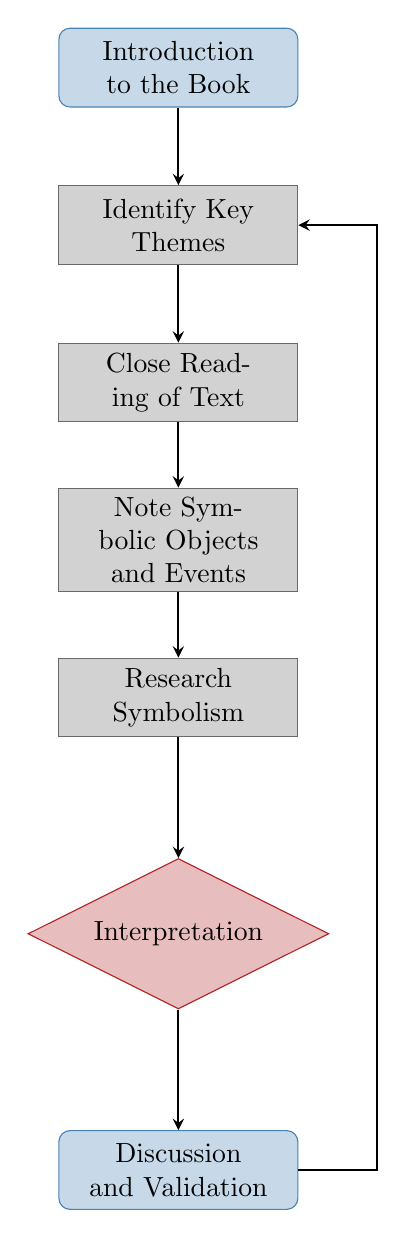What is the first step in the flow chart? The first step is labeled "Introduction to the Book," indicating the starting point of the process.
Answer: Introduction to the Book How many nodes are present in the flow chart? By counting all the distinct steps and decisions in the flow chart, there are a total of six nodes.
Answer: 6 What is the last step before discussion and validation? The last step before discussion and validation is "Interpretation," which leads into the final discussion phase of the process.
Answer: Interpretation Which step follows 'Research Symbolism'? The step that follows 'Research Symbolism' is 'Interpretation,' suggesting a continued process of analyzing the gathered symbols.
Answer: Interpretation What does the arrow from 'Discussion and Validation' point back to? The arrow from 'Discussion and Validation' points back to 'Identify Key Themes,' indicating a cycle where discussions may lead to revisiting earlier steps.
Answer: Identify Key Themes What type of nodes are 'Introduction to the Book' and 'Discussion and Validation'? Both 'Introduction to the Book' and 'Discussion and Validation' are classified as startstop nodes, indicating they serve as start or end points in the process.
Answer: startstop What action is described in the 'Close Reading of Text' step? The 'Close Reading of Text' step entails performing an in-depth reading of particular passages that are believed to hold symbolism.
Answer: Close Reading of Text Which step focuses on researching common symbols? The step that focuses on researching common symbols is 'Research Symbolism,' where one can gather additional context and meanings.
Answer: Research Symbolism What is the significance of the 'Interpretation' node in this flow? The 'Interpretation' node is crucial as it represents the analysis of how symbols link to themes in the book, forming an essential part of the symbolic understanding process.
Answer: Analyze how symbols relate to themes 